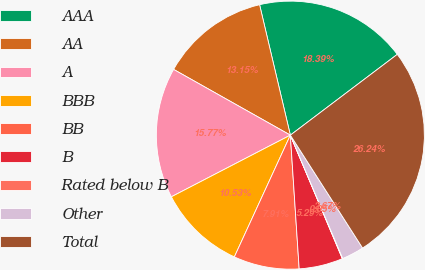Convert chart. <chart><loc_0><loc_0><loc_500><loc_500><pie_chart><fcel>AAA<fcel>AA<fcel>A<fcel>BBB<fcel>BB<fcel>B<fcel>Rated below B<fcel>Other<fcel>Total<nl><fcel>18.39%<fcel>13.15%<fcel>15.77%<fcel>10.53%<fcel>7.91%<fcel>5.29%<fcel>0.05%<fcel>2.67%<fcel>26.24%<nl></chart> 